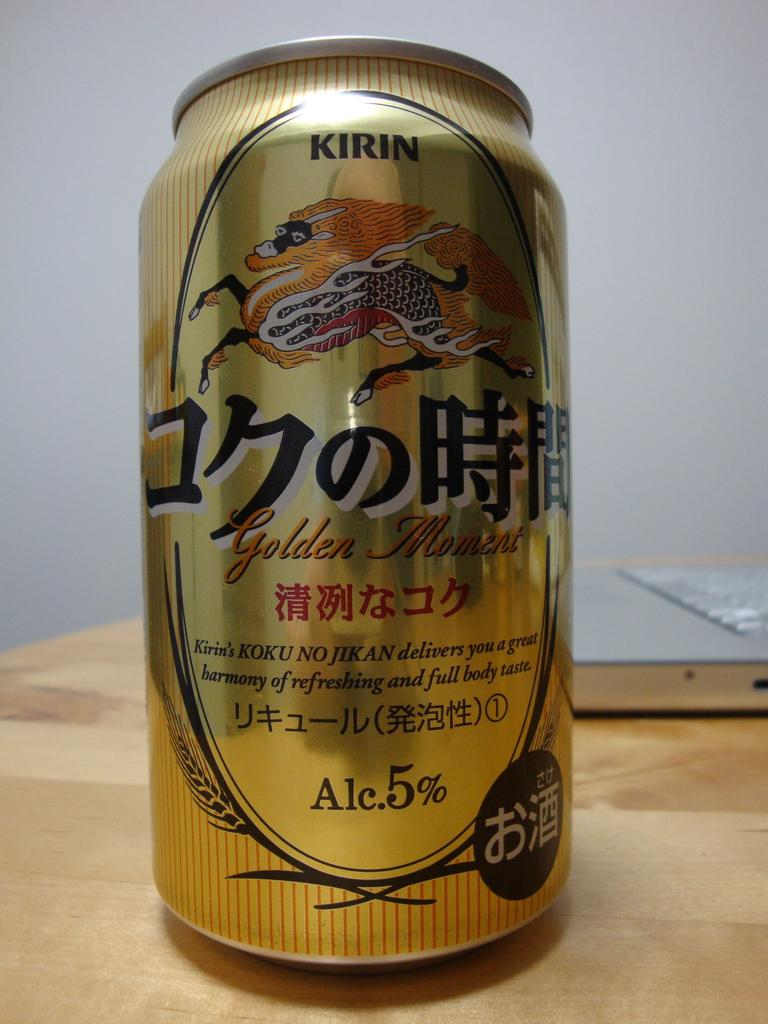<image>
Provide a brief description of the given image. Can of Kirin Golden Moment containing 5% alcohol. 